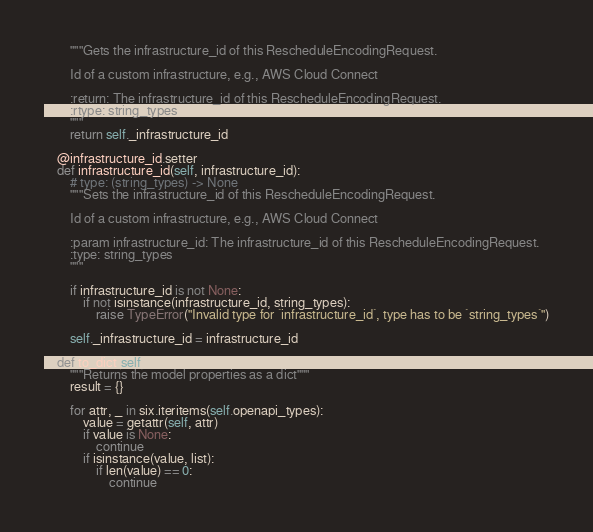Convert code to text. <code><loc_0><loc_0><loc_500><loc_500><_Python_>        """Gets the infrastructure_id of this RescheduleEncodingRequest.

        Id of a custom infrastructure, e.g., AWS Cloud Connect

        :return: The infrastructure_id of this RescheduleEncodingRequest.
        :rtype: string_types
        """
        return self._infrastructure_id

    @infrastructure_id.setter
    def infrastructure_id(self, infrastructure_id):
        # type: (string_types) -> None
        """Sets the infrastructure_id of this RescheduleEncodingRequest.

        Id of a custom infrastructure, e.g., AWS Cloud Connect

        :param infrastructure_id: The infrastructure_id of this RescheduleEncodingRequest.
        :type: string_types
        """

        if infrastructure_id is not None:
            if not isinstance(infrastructure_id, string_types):
                raise TypeError("Invalid type for `infrastructure_id`, type has to be `string_types`")

        self._infrastructure_id = infrastructure_id

    def to_dict(self):
        """Returns the model properties as a dict"""
        result = {}

        for attr, _ in six.iteritems(self.openapi_types):
            value = getattr(self, attr)
            if value is None:
                continue
            if isinstance(value, list):
                if len(value) == 0:
                    continue</code> 